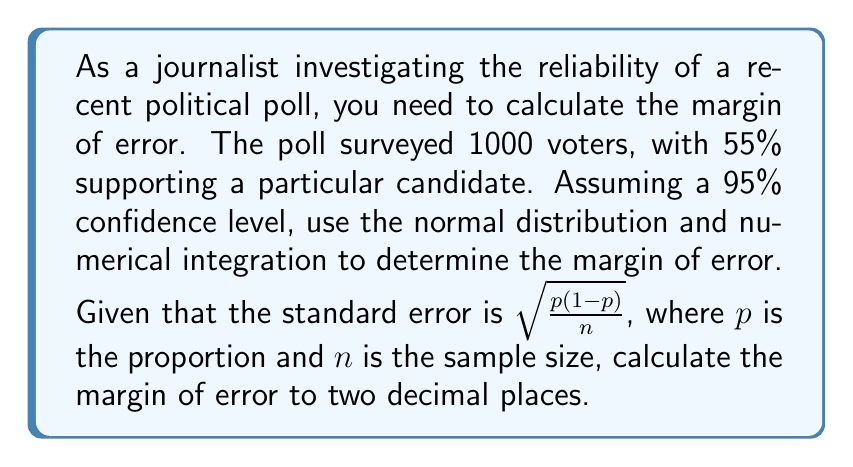Solve this math problem. 1. Calculate the standard error:
   $SE = \sqrt{\frac{p(1-p)}{n}} = \sqrt{\frac{0.55(1-0.55)}{1000}} = \sqrt{\frac{0.2475}{1000}} \approx 0.0157$

2. For a 95% confidence level, we need to find the z-score that corresponds to the area between -z and z equal to 0.95.

3. We can use numerical integration to find this z-score. The standard normal distribution function is:
   $f(x) = \frac{1}{\sqrt{2\pi}}e^{-\frac{x^2}{2}}$

4. We need to find z such that:
   $\int_{-z}^{z} \frac{1}{\sqrt{2\pi}}e^{-\frac{x^2}{2}} dx = 0.95$

5. Using Simpson's rule with 1000 subintervals, we can approximate this integral and find that z ≈ 1.96.

6. The margin of error is calculated as:
   $ME = z \cdot SE = 1.96 \cdot 0.0157 \approx 0.0308$

7. Converting to a percentage and rounding to two decimal places:
   $ME \approx 3.08\%$
Answer: 3.08% 